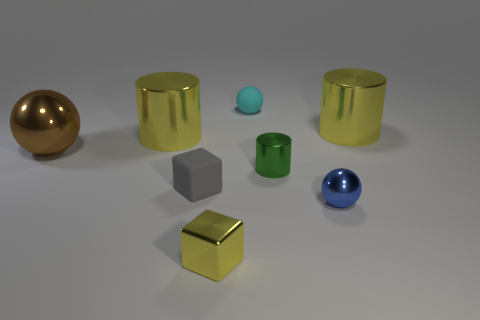What is the shape of the gray thing?
Your response must be concise. Cube. Is there a thing that has the same color as the metallic block?
Your answer should be compact. Yes. Is the number of big metallic cylinders right of the tiny gray matte object greater than the number of purple metallic cubes?
Provide a short and direct response. Yes. Does the big brown metal object have the same shape as the tiny rubber thing that is behind the big brown metal object?
Make the answer very short. Yes. Are there any small blue rubber cylinders?
Provide a succinct answer. No. What number of small objects are either matte blocks or purple spheres?
Make the answer very short. 1. Is the number of gray matte blocks that are on the left side of the tiny rubber ball greater than the number of small gray matte cubes that are left of the brown metallic sphere?
Your answer should be compact. Yes. Is the small yellow cube made of the same material as the tiny object that is behind the green metal object?
Keep it short and to the point. No. What color is the small shiny cylinder?
Ensure brevity in your answer.  Green. What shape is the rubber object that is right of the small metal block?
Make the answer very short. Sphere. 